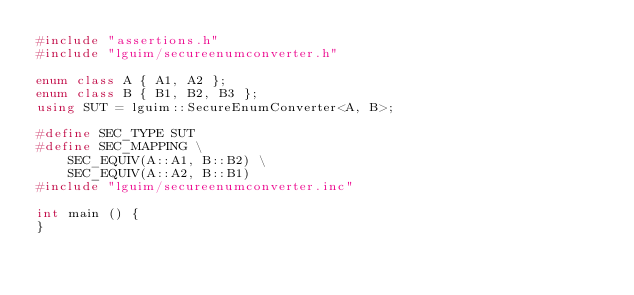<code> <loc_0><loc_0><loc_500><loc_500><_C++_>#include "assertions.h"
#include "lguim/secureenumconverter.h"

enum class A { A1, A2 };
enum class B { B1, B2, B3 };
using SUT = lguim::SecureEnumConverter<A, B>;

#define SEC_TYPE SUT
#define SEC_MAPPING \
    SEC_EQUIV(A::A1, B::B2) \
    SEC_EQUIV(A::A2, B::B1)
#include "lguim/secureenumconverter.inc"

int main () {
}
</code> 